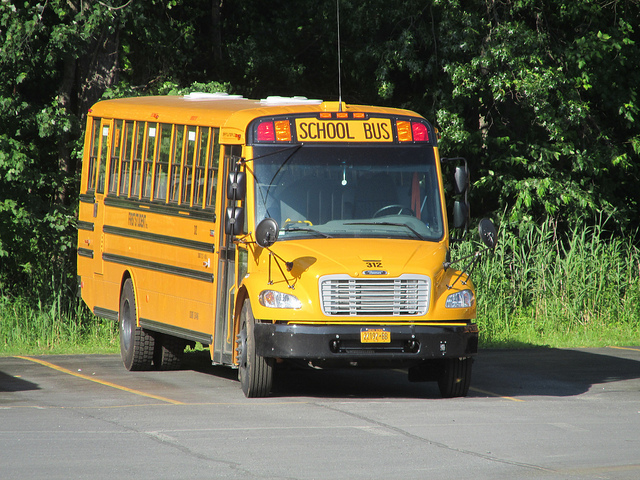<image>How far do you have to keep back from the bus? It is ambiguous how far one needs to keep back from the bus. The reported distance varies greatly, ranging from 10 feet to 1000 feet. How far do you have to keep back from the bus? I don't know how far you have to keep back from the bus. It can be 10 feet, 30 feet, or even 50 feet. 